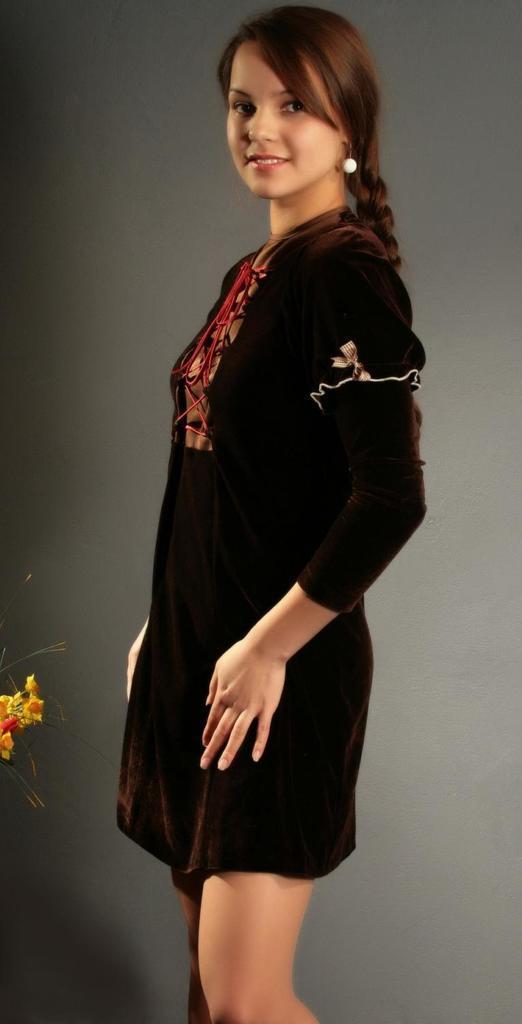Could you give a brief overview of what you see in this image? In this image I can see woman is standing and wearing black dress. Background is in grey and black color. We can see yellow color flower. 